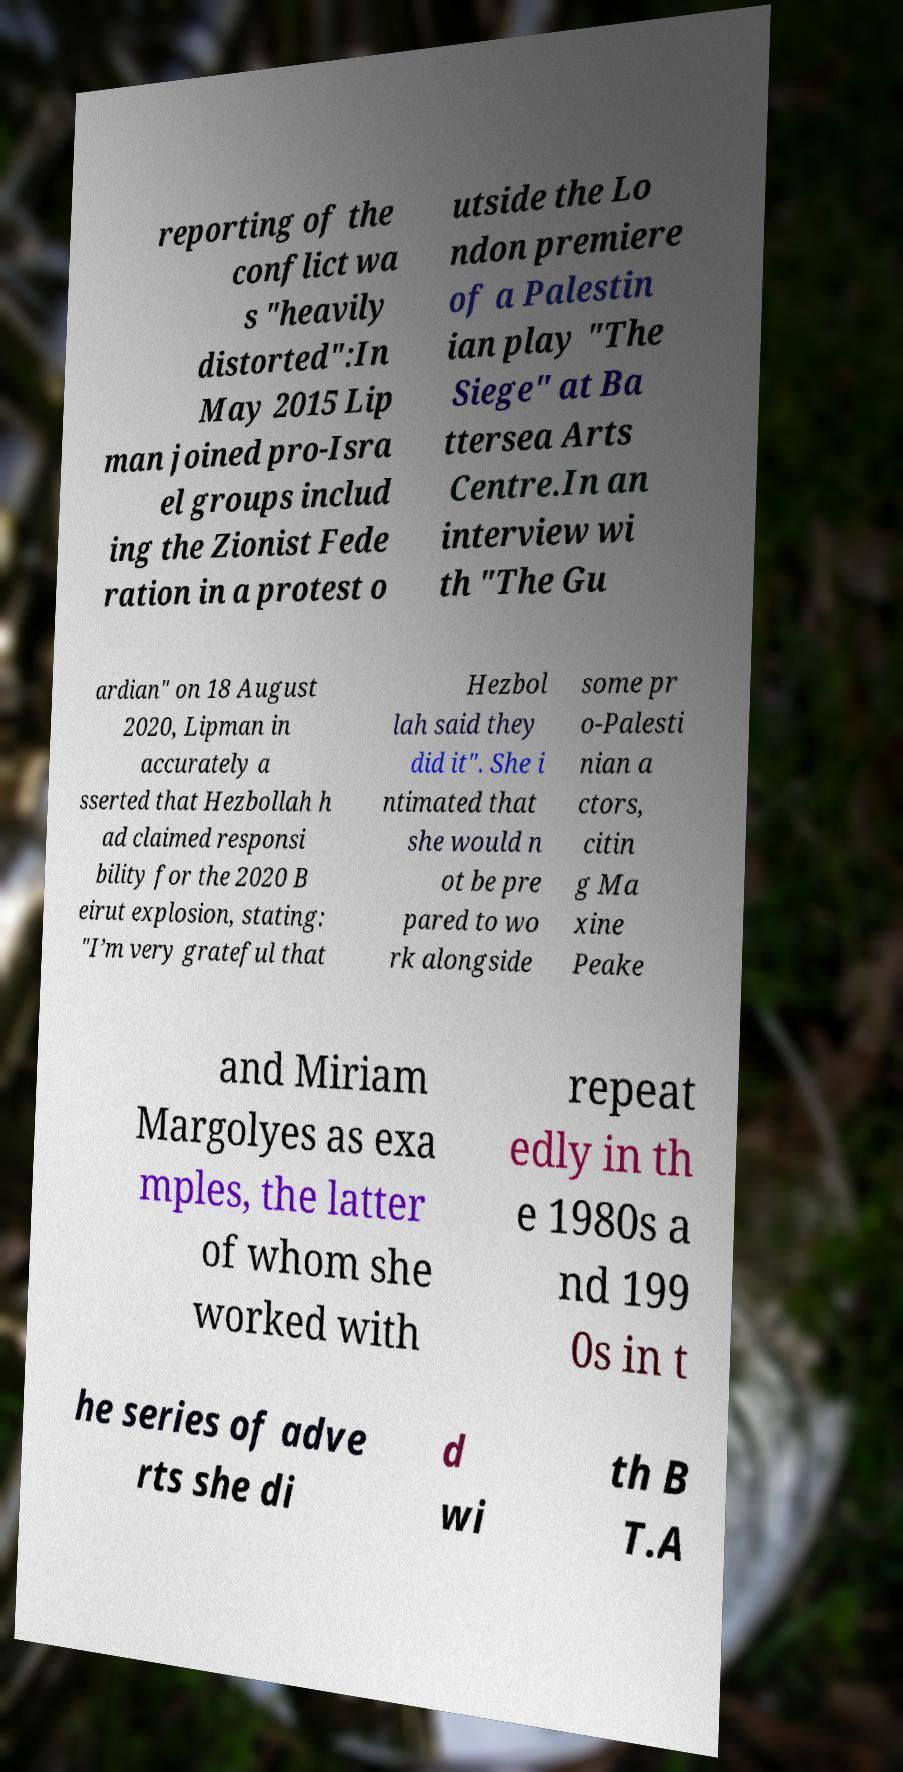For documentation purposes, I need the text within this image transcribed. Could you provide that? reporting of the conflict wa s "heavily distorted":In May 2015 Lip man joined pro-Isra el groups includ ing the Zionist Fede ration in a protest o utside the Lo ndon premiere of a Palestin ian play "The Siege" at Ba ttersea Arts Centre.In an interview wi th "The Gu ardian" on 18 August 2020, Lipman in accurately a sserted that Hezbollah h ad claimed responsi bility for the 2020 B eirut explosion, stating: "I’m very grateful that Hezbol lah said they did it". She i ntimated that she would n ot be pre pared to wo rk alongside some pr o-Palesti nian a ctors, citin g Ma xine Peake and Miriam Margolyes as exa mples, the latter of whom she worked with repeat edly in th e 1980s a nd 199 0s in t he series of adve rts she di d wi th B T.A 